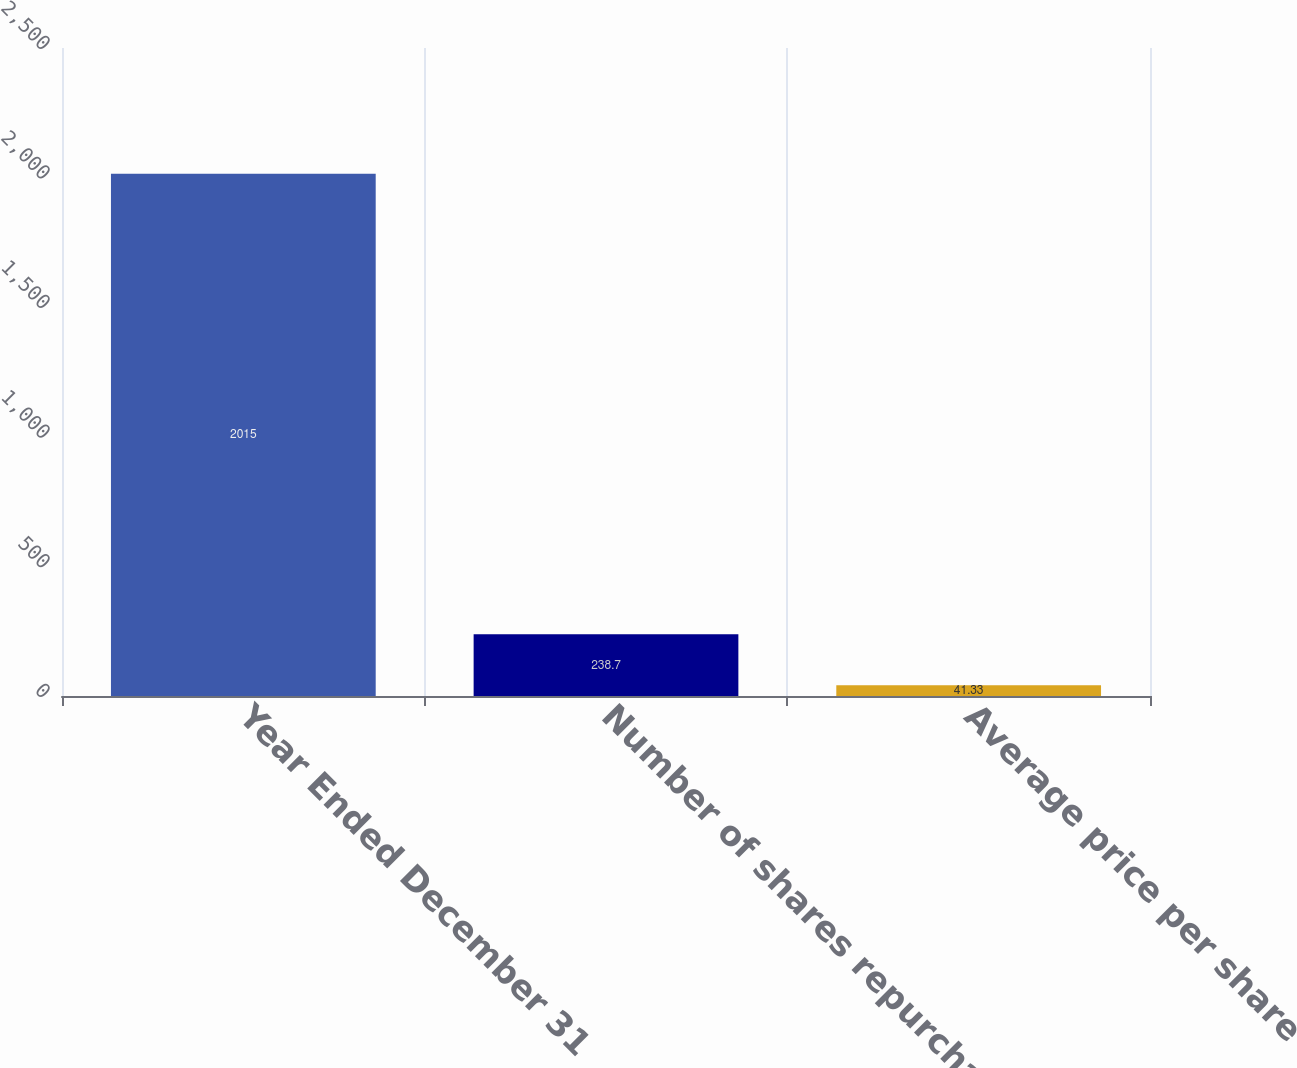<chart> <loc_0><loc_0><loc_500><loc_500><bar_chart><fcel>Year Ended December 31<fcel>Number of shares repurchased<fcel>Average price per share<nl><fcel>2015<fcel>238.7<fcel>41.33<nl></chart> 